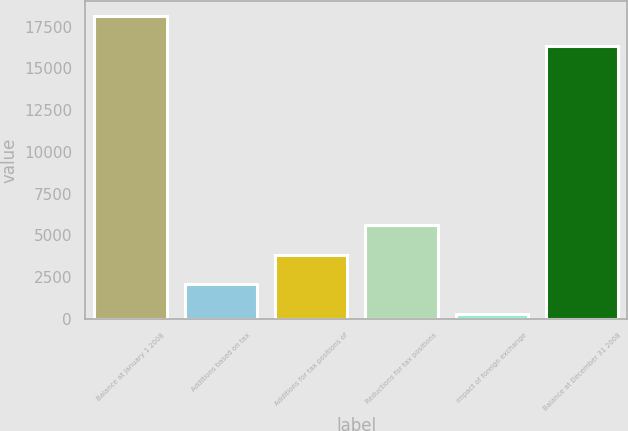<chart> <loc_0><loc_0><loc_500><loc_500><bar_chart><fcel>Balance at January 1 2008<fcel>Additions based on tax<fcel>Additions for tax positions of<fcel>Reductions for tax positions<fcel>Impact of foreign exchange<fcel>Balance at December 31 2008<nl><fcel>18122.4<fcel>2072.4<fcel>3847.8<fcel>5623.2<fcel>297<fcel>16347<nl></chart> 